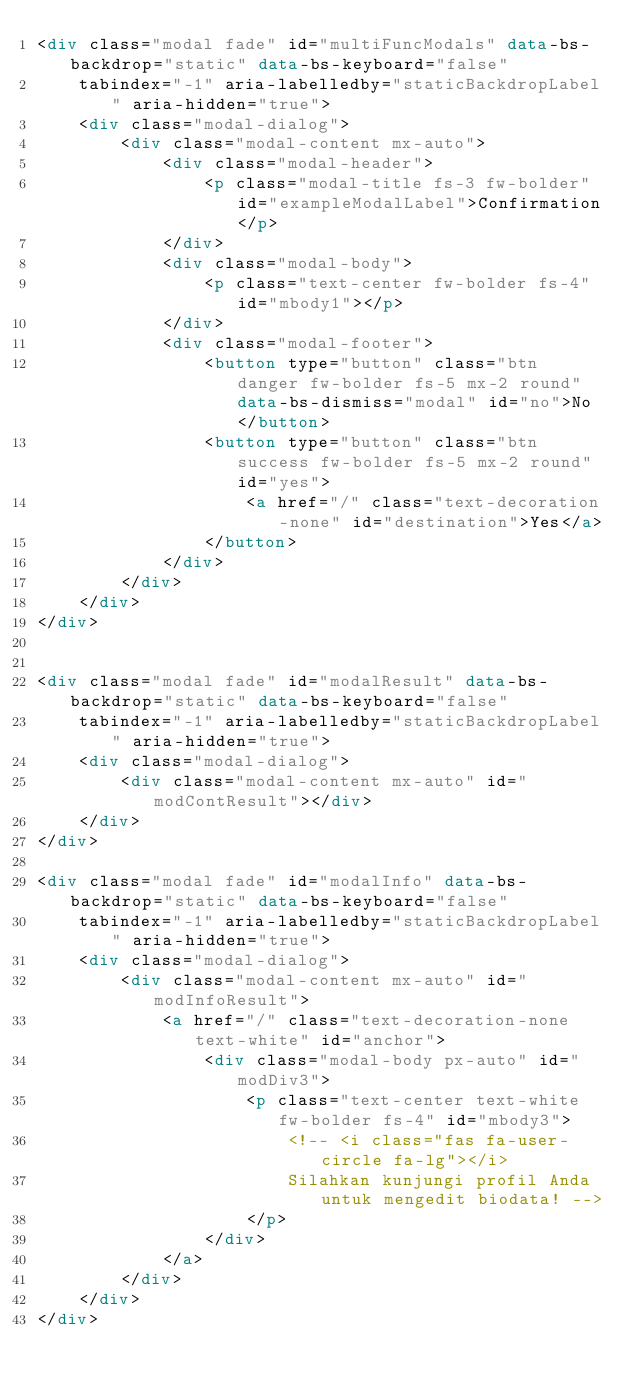Convert code to text. <code><loc_0><loc_0><loc_500><loc_500><_HTML_><div class="modal fade" id="multiFuncModals" data-bs-backdrop="static" data-bs-keyboard="false" 
    tabindex="-1" aria-labelledby="staticBackdropLabel" aria-hidden="true">
    <div class="modal-dialog">
        <div class="modal-content mx-auto">
            <div class="modal-header">
                <p class="modal-title fs-3 fw-bolder" id="exampleModalLabel">Confirmation</p>
            </div>
            <div class="modal-body">
                <p class="text-center fw-bolder fs-4" id="mbody1"></p>
            </div>
            <div class="modal-footer">
                <button type="button" class="btn danger fw-bolder fs-5 mx-2 round" data-bs-dismiss="modal" id="no">No</button>
                <button type="button" class="btn success fw-bolder fs-5 mx-2 round" id="yes">
                    <a href="/" class="text-decoration-none" id="destination">Yes</a>
                </button>
            </div>
        </div>
    </div>
</div>


<div class="modal fade" id="modalResult" data-bs-backdrop="static" data-bs-keyboard="false" 
    tabindex="-1" aria-labelledby="staticBackdropLabel" aria-hidden="true">
    <div class="modal-dialog">
        <div class="modal-content mx-auto" id="modContResult"></div>
    </div>
</div>

<div class="modal fade" id="modalInfo" data-bs-backdrop="static" data-bs-keyboard="false" 
    tabindex="-1" aria-labelledby="staticBackdropLabel" aria-hidden="true">
    <div class="modal-dialog">
        <div class="modal-content mx-auto" id="modInfoResult">
            <a href="/" class="text-decoration-none text-white" id="anchor">
                <div class="modal-body px-auto" id="modDiv3">
                    <p class="text-center text-white fw-bolder fs-4" id="mbody3">
                        <!-- <i class="fas fa-user-circle fa-lg"></i> 
                        Silahkan kunjungi profil Anda untuk mengedit biodata! -->
                    </p>
                </div>
            </a>
        </div>
    </div>
</div></code> 